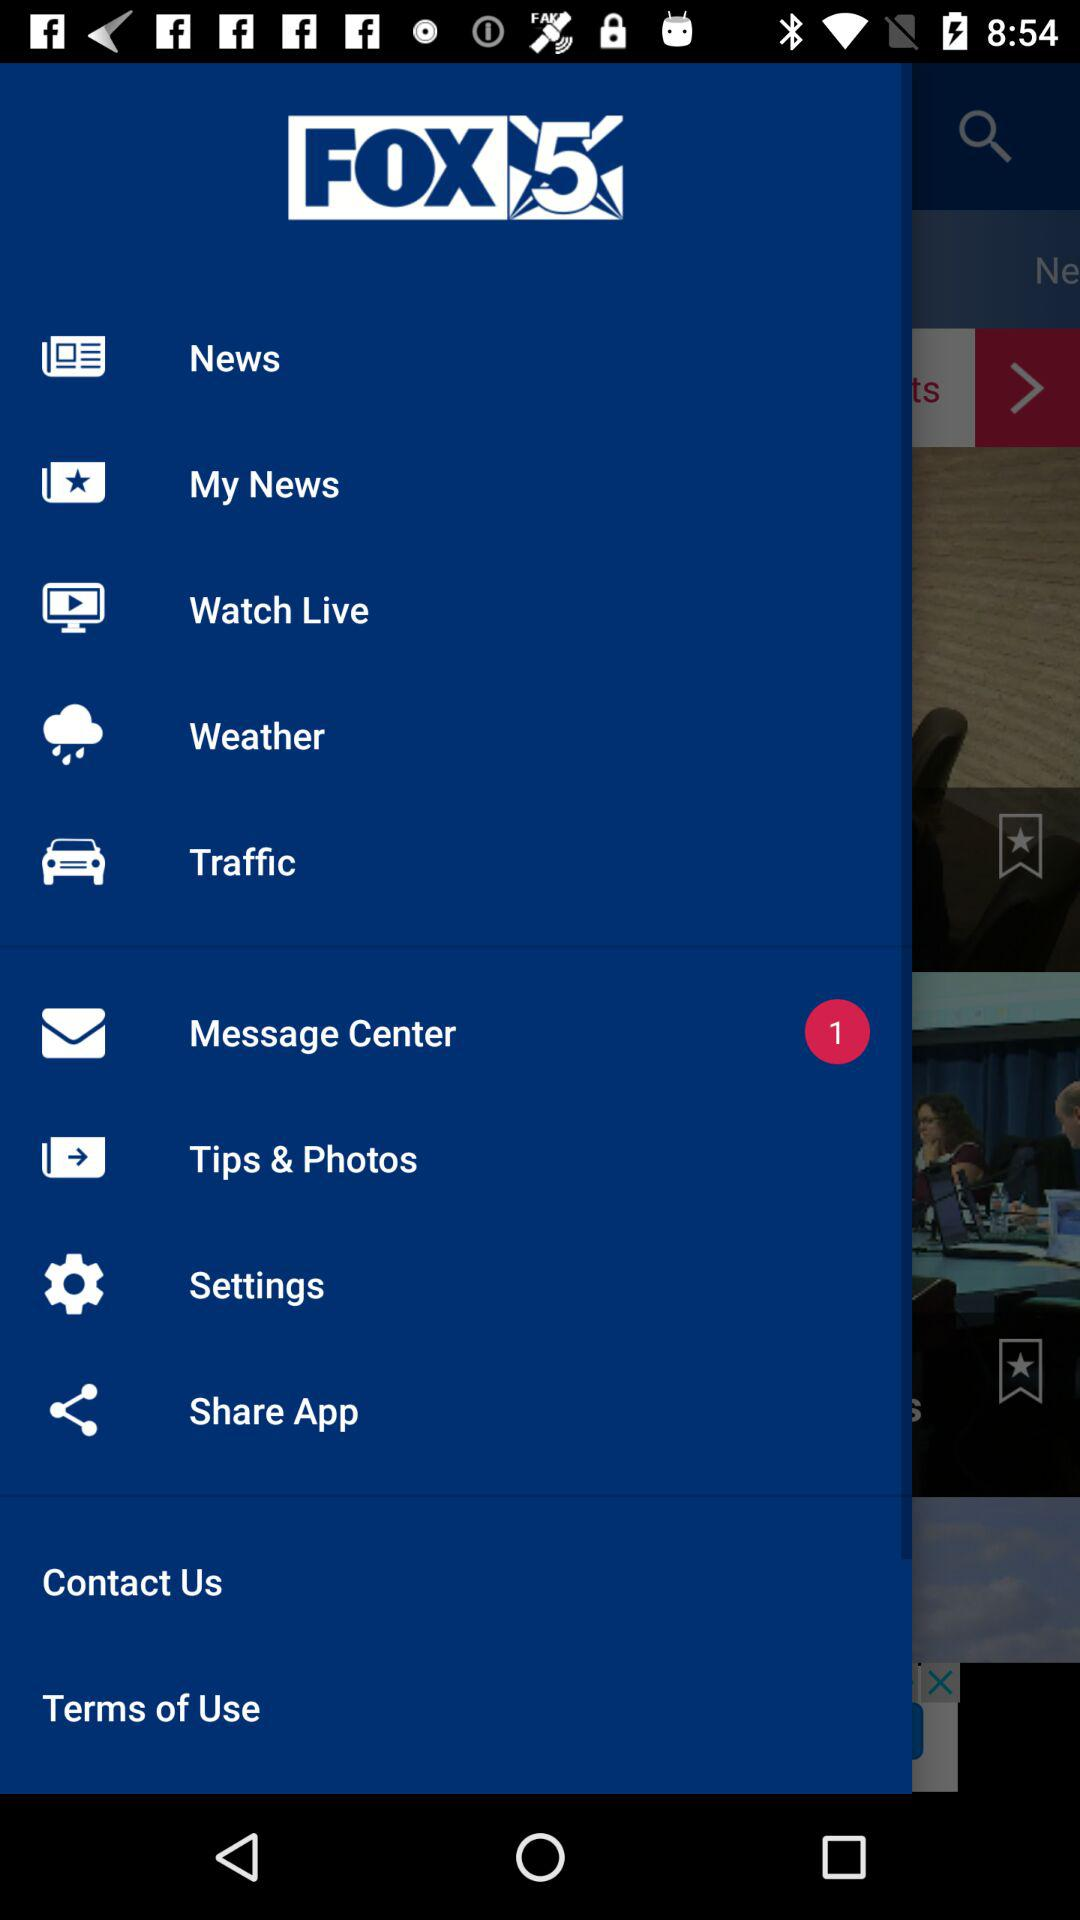When was the most recent news posted?
When the provided information is insufficient, respond with <no answer>. <no answer> 